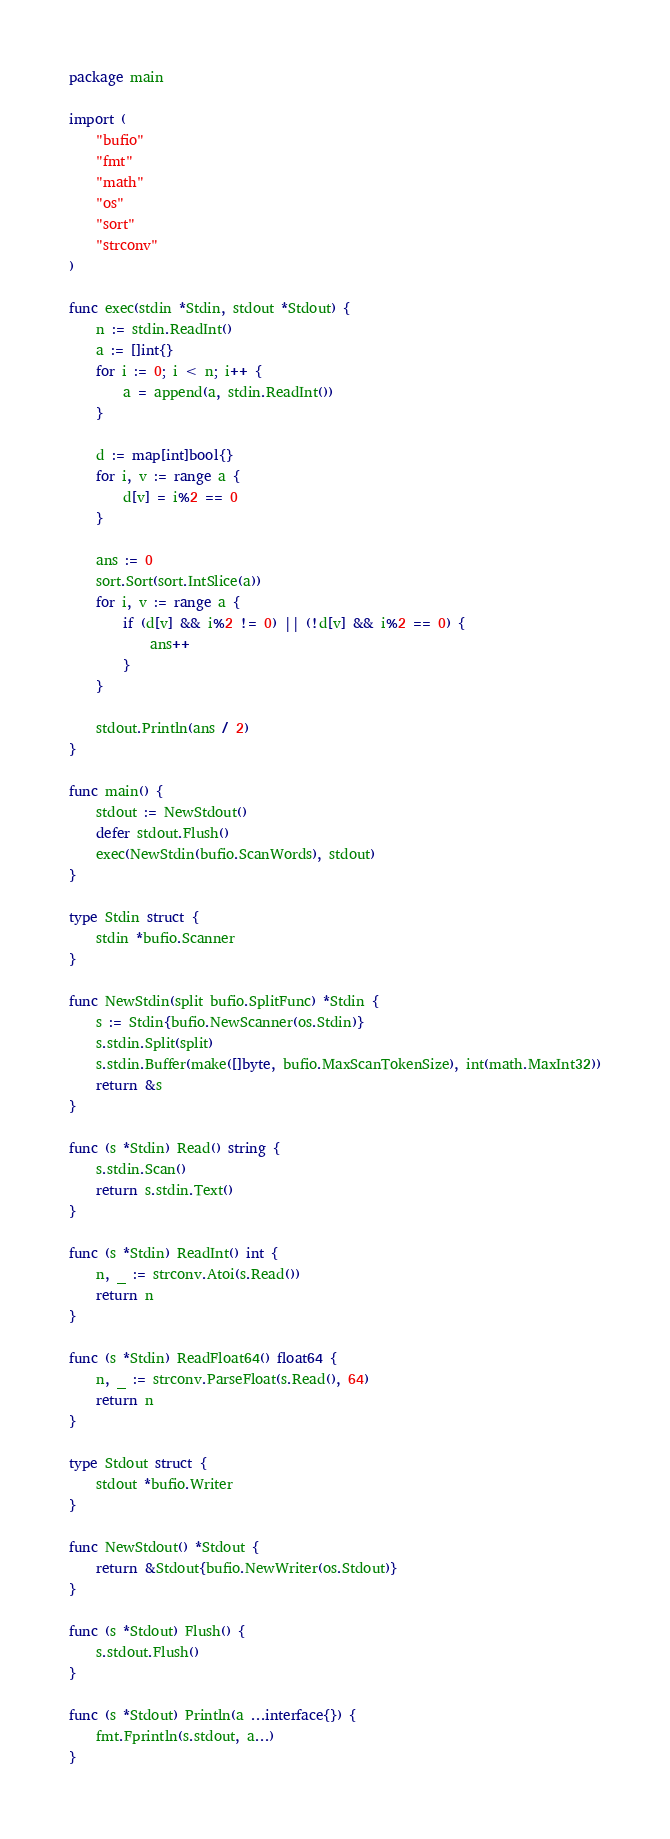<code> <loc_0><loc_0><loc_500><loc_500><_Go_>package main

import (
	"bufio"
	"fmt"
	"math"
	"os"
	"sort"
	"strconv"
)

func exec(stdin *Stdin, stdout *Stdout) {
	n := stdin.ReadInt()
	a := []int{}
	for i := 0; i < n; i++ {
		a = append(a, stdin.ReadInt())
	}

	d := map[int]bool{}
	for i, v := range a {
		d[v] = i%2 == 0
	}

	ans := 0
	sort.Sort(sort.IntSlice(a))
	for i, v := range a {
		if (d[v] && i%2 != 0) || (!d[v] && i%2 == 0) {
			ans++
		}
	}

	stdout.Println(ans / 2)
}

func main() {
	stdout := NewStdout()
	defer stdout.Flush()
	exec(NewStdin(bufio.ScanWords), stdout)
}

type Stdin struct {
	stdin *bufio.Scanner
}

func NewStdin(split bufio.SplitFunc) *Stdin {
	s := Stdin{bufio.NewScanner(os.Stdin)}
	s.stdin.Split(split)
	s.stdin.Buffer(make([]byte, bufio.MaxScanTokenSize), int(math.MaxInt32))
	return &s
}

func (s *Stdin) Read() string {
	s.stdin.Scan()
	return s.stdin.Text()
}

func (s *Stdin) ReadInt() int {
	n, _ := strconv.Atoi(s.Read())
	return n
}

func (s *Stdin) ReadFloat64() float64 {
	n, _ := strconv.ParseFloat(s.Read(), 64)
	return n
}

type Stdout struct {
	stdout *bufio.Writer
}

func NewStdout() *Stdout {
	return &Stdout{bufio.NewWriter(os.Stdout)}
}

func (s *Stdout) Flush() {
	s.stdout.Flush()
}

func (s *Stdout) Println(a ...interface{}) {
	fmt.Fprintln(s.stdout, a...)
}
</code> 